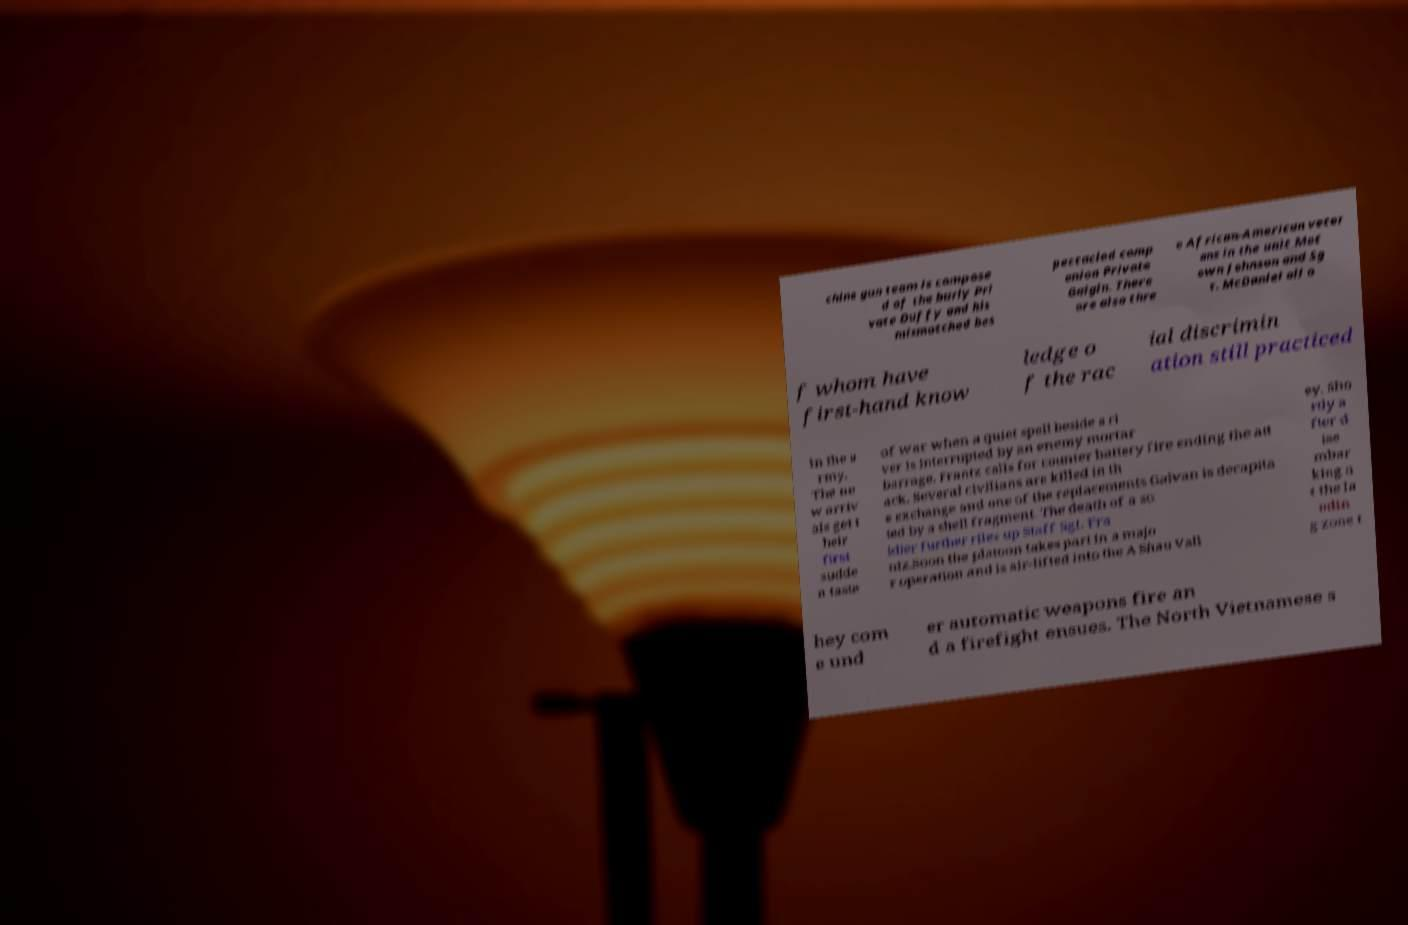Can you accurately transcribe the text from the provided image for me? chine gun team is compose d of the burly Pri vate Duffy and his mismatched bes pectacled comp anion Private Gaigin. There are also thre e African-American veter ans in the unit Mot own Johnson and Sg t. McDaniel all o f whom have first-hand know ledge o f the rac ial discrimin ation still practiced in the a rmy. The ne w arriv als get t heir first sudde n taste of war when a quiet spell beside a ri ver is interrupted by an enemy mortar barrage. Frantz calls for counter battery fire ending the att ack. Several civilians are killed in th e exchange and one of the replacements Galvan is decapita ted by a shell fragment. The death of a so ldier further riles up Staff Sgt. Fra ntz.Soon the platoon takes part in a majo r operation and is air-lifted into the A Shau Vall ey. Sho rtly a fter d ise mbar king a t the la ndin g zone t hey com e und er automatic weapons fire an d a firefight ensues. The North Vietnamese s 